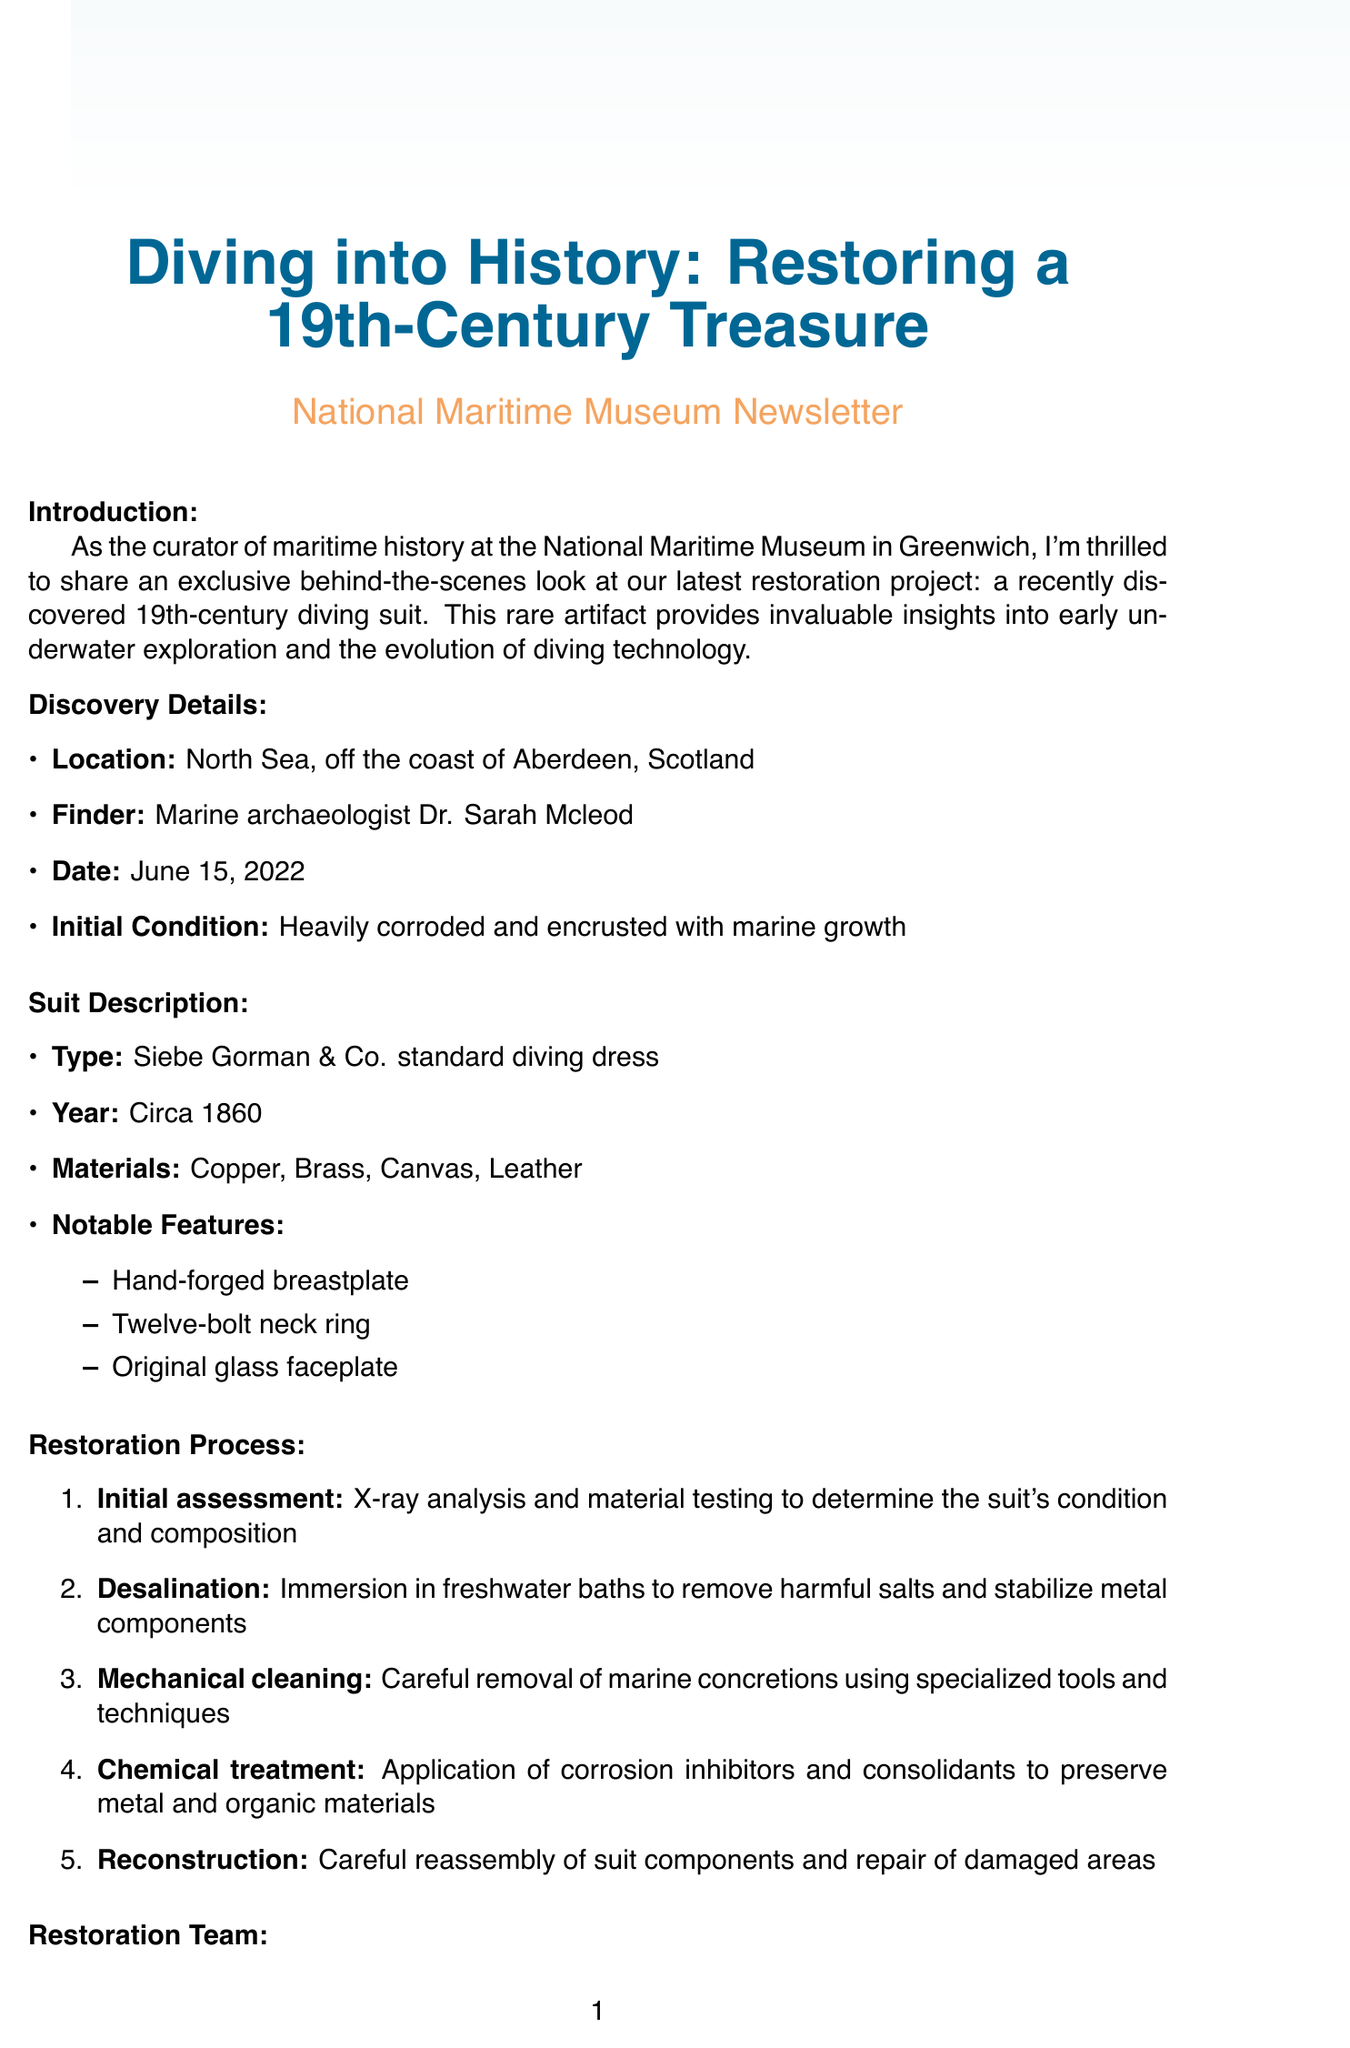What is the title of the newsletter? The title of the newsletter is indicated at the beginning of the document, which introduces the restoration project.
Answer: Diving into History: Restoring a 19th-Century Treasure Who found the diving suit? The finder of the diving suit is mentioned in the discovery details section, which credits an archaeological professional with the find.
Answer: Marine archaeologist Dr. Sarah Mcleod What materials is the diving suit made of? The suit description section lists the materials used in the construction of the diving suit.
Answer: Copper, Brass, Canvas, Leather How many steps are in the restoration process? The restoration process describes a series of actions conducted to restore the suit, counting the total steps listed.
Answer: Five What is the opening date of the exhibition? The exhibit plans specify the opening date for the exhibition related to the diving suit.
Answer: September 1, 2023 What role does Dr. Emma Watson have in the restoration team? The restoration team section identifies Dr. Emma Watson’s position and her specialty in the team.
Answer: Lead Conservator What is one notable feature of the diving suit? The suit description lists several unique characteristics of the diving suit, of which at least one is highlighted.
Answer: Hand-forged breastplate Which gallery will host the exhibition? Information about the location of the exhibition is provided in the exhibition plans part of the document.
Answer: Special Collections Gallery, National Maritime Museum 